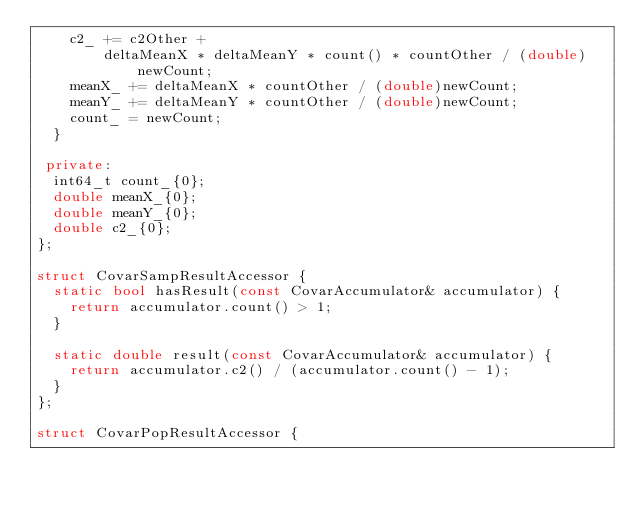Convert code to text. <code><loc_0><loc_0><loc_500><loc_500><_C++_>    c2_ += c2Other +
        deltaMeanX * deltaMeanY * count() * countOther / (double)newCount;
    meanX_ += deltaMeanX * countOther / (double)newCount;
    meanY_ += deltaMeanY * countOther / (double)newCount;
    count_ = newCount;
  }

 private:
  int64_t count_{0};
  double meanX_{0};
  double meanY_{0};
  double c2_{0};
};

struct CovarSampResultAccessor {
  static bool hasResult(const CovarAccumulator& accumulator) {
    return accumulator.count() > 1;
  }

  static double result(const CovarAccumulator& accumulator) {
    return accumulator.c2() / (accumulator.count() - 1);
  }
};

struct CovarPopResultAccessor {</code> 